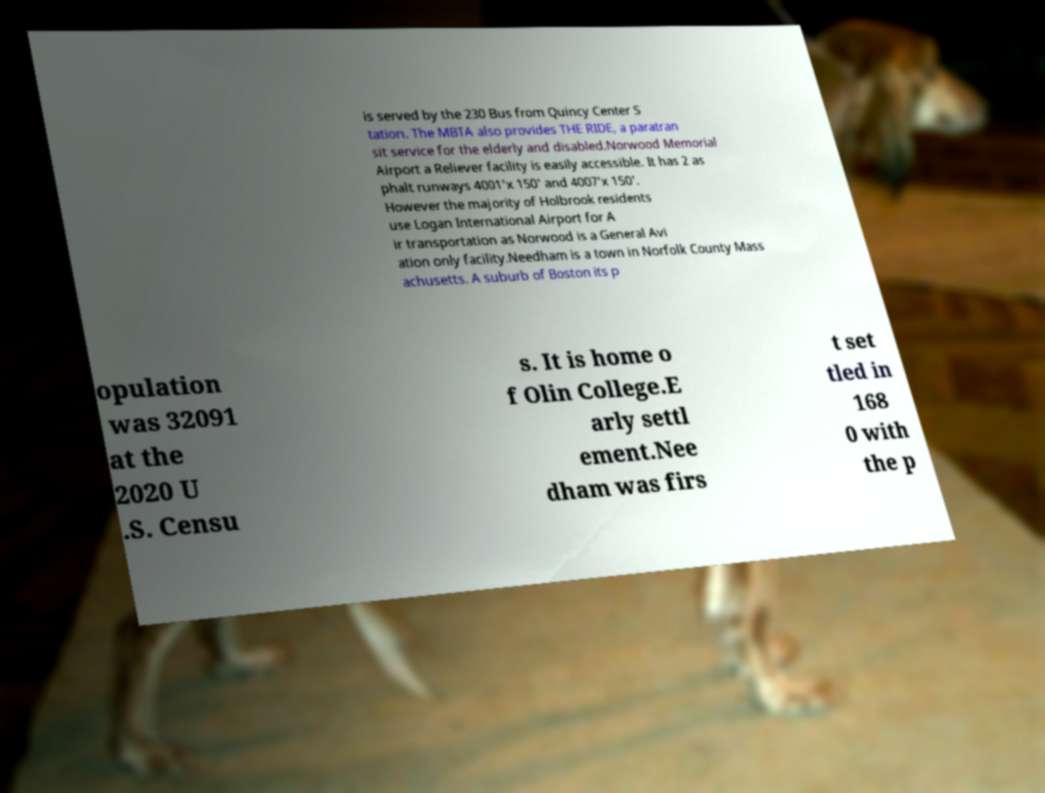Can you accurately transcribe the text from the provided image for me? is served by the 230 Bus from Quincy Center S tation. The MBTA also provides THE RIDE, a paratran sit service for the elderly and disabled.Norwood Memorial Airport a Reliever facility is easily accessible. It has 2 as phalt runways 4001'x 150' and 4007'x 150'. However the majority of Holbrook residents use Logan International Airport for A ir transportation as Norwood is a General Avi ation only facility.Needham is a town in Norfolk County Mass achusetts. A suburb of Boston its p opulation was 32091 at the 2020 U .S. Censu s. It is home o f Olin College.E arly settl ement.Nee dham was firs t set tled in 168 0 with the p 